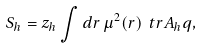<formula> <loc_0><loc_0><loc_500><loc_500>S _ { h } = z _ { h } \int d r \, \mu ^ { 2 } ( r ) \ t r A _ { h } q ,</formula> 